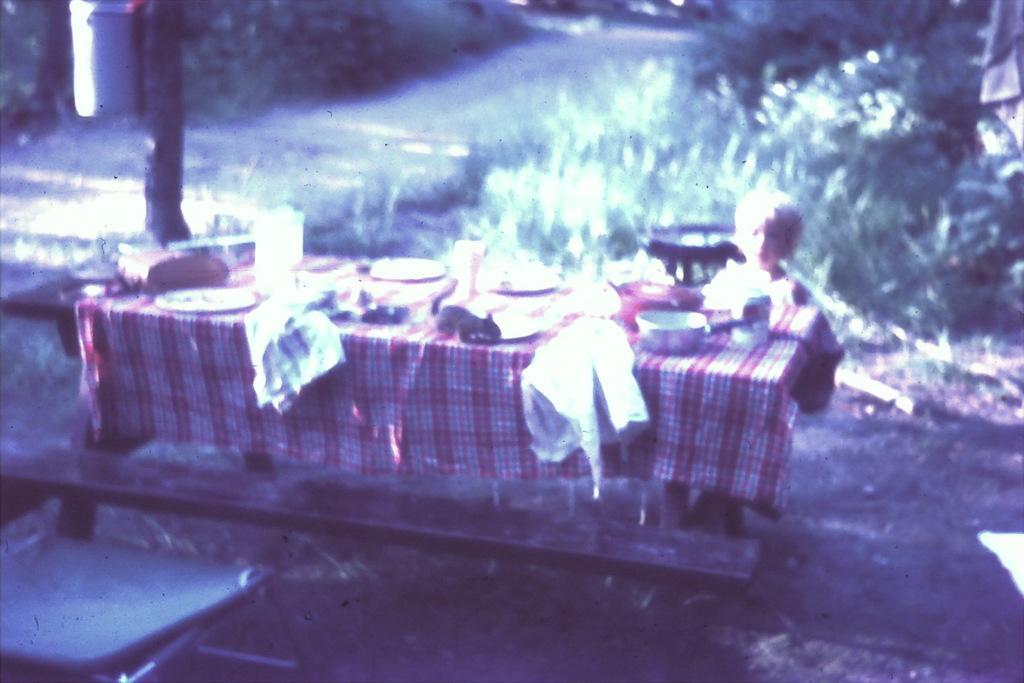Describe this image in one or two sentences. At the center of the image there is a little boy. In front of the him there is a table. On the table there are many food items and clothes, beside the table there is a poll. In the background there is a grass. 